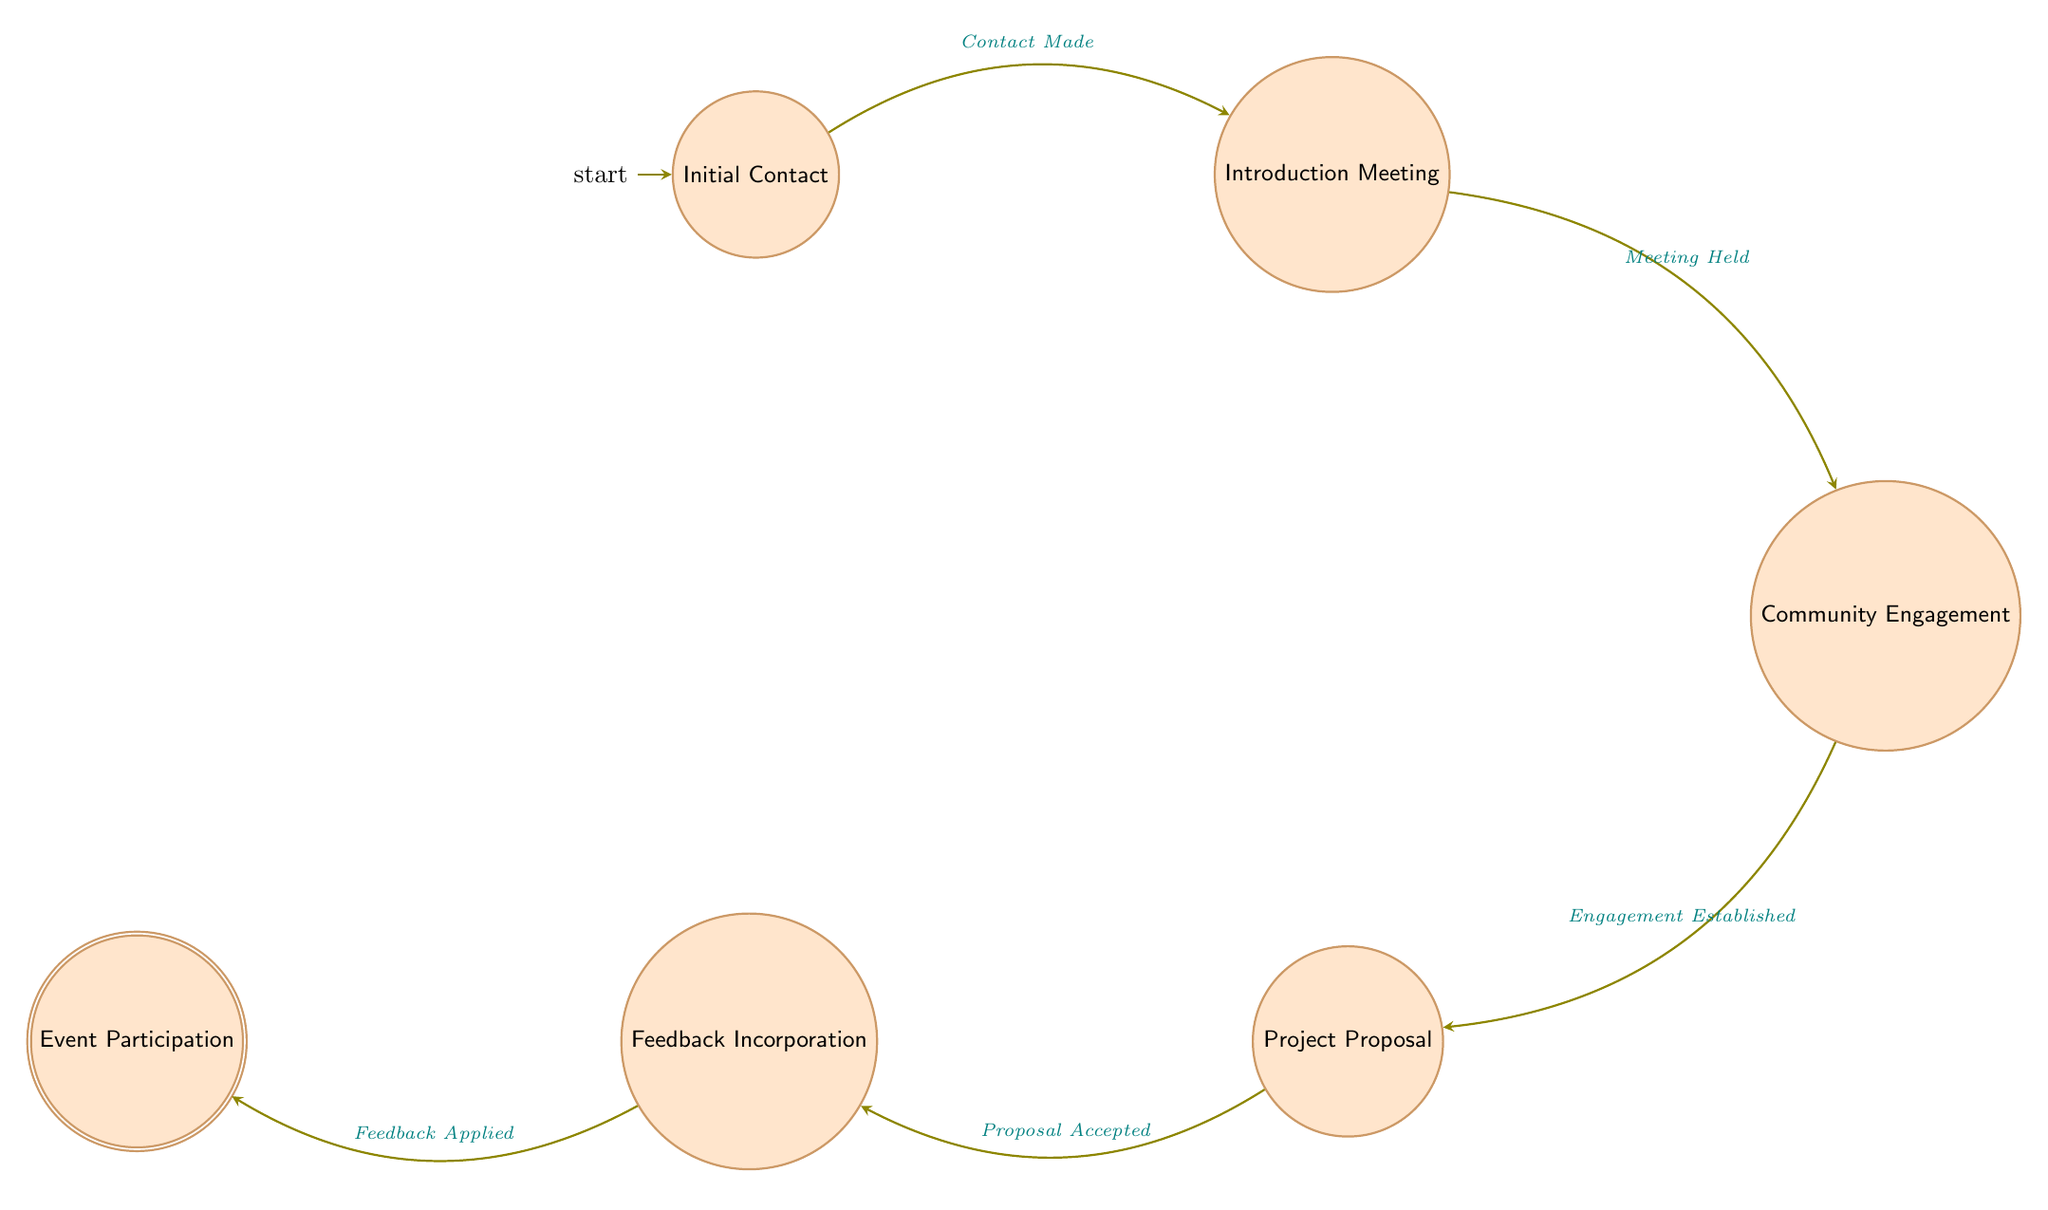What is the first state in the diagram? The diagram starts with the state labeled "Initial Contact," which is the first state in the sequence.
Answer: Initial Contact How many states are there in total? The diagram has six distinct states that represent the various stages of engaging with local communities.
Answer: Six What transition occurs from "Initial Contact" to "Introduction Meeting"? The transition from "Initial Contact" to "Introduction Meeting" occurs on the event labeled "Contact Made," which signifies a successful initial outreach.
Answer: Contact Made What is the last state in the process? The last state in the Finite State Machine is "Event Participation," indicating the final step after all earlier processes have been completed.
Answer: Event Participation Which state transitions to "Community Engagement"? The state that transitions to "Community Engagement" is "Introduction Meeting," following the successful arrangement and holding of an introductory meeting.
Answer: Introduction Meeting How many transitions are depicted in the diagram? There are five transitions illustrated in the diagram, showing the progression from one state to another throughout the engagement process.
Answer: Five What feedback is incorporated after the proposal is accepted? After the proposal is accepted, feedback from community leaders and members is incorporated into the project plan, which is the aim of the "Feedback Incorporation" state.
Answer: Feedback Which state indicates engagement has been established? The state that indicates engagement has been established is "Community Engagement," which follows the successful initial meetings and interactions with community members.
Answer: Community Engagement What is required before moving to "Feedback Incorporation"? Before moving to "Feedback Incorporation," the project proposal must be accepted, as indicated by the transition from "Project Proposal."
Answer: Proposal Accepted 